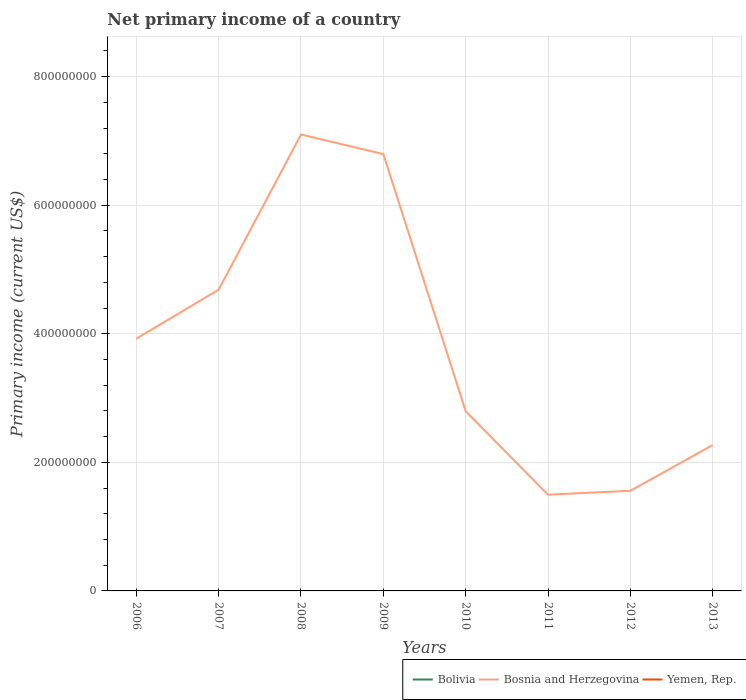Across all years, what is the maximum primary income in Bolivia?
Keep it short and to the point. 0. What is the total primary income in Bosnia and Herzegovina in the graph?
Provide a short and direct response. -2.87e+08. What is the difference between the highest and the second highest primary income in Bosnia and Herzegovina?
Your answer should be compact. 5.60e+08. Is the primary income in Bosnia and Herzegovina strictly greater than the primary income in Bolivia over the years?
Give a very brief answer. No. How many years are there in the graph?
Keep it short and to the point. 8. What is the difference between two consecutive major ticks on the Y-axis?
Give a very brief answer. 2.00e+08. Does the graph contain any zero values?
Your response must be concise. Yes. Does the graph contain grids?
Offer a terse response. Yes. How are the legend labels stacked?
Make the answer very short. Horizontal. What is the title of the graph?
Offer a very short reply. Net primary income of a country. What is the label or title of the Y-axis?
Your answer should be compact. Primary income (current US$). What is the Primary income (current US$) in Bosnia and Herzegovina in 2006?
Your response must be concise. 3.92e+08. What is the Primary income (current US$) of Yemen, Rep. in 2006?
Keep it short and to the point. 0. What is the Primary income (current US$) in Bosnia and Herzegovina in 2007?
Offer a terse response. 4.69e+08. What is the Primary income (current US$) of Yemen, Rep. in 2007?
Your answer should be compact. 0. What is the Primary income (current US$) of Bolivia in 2008?
Keep it short and to the point. 0. What is the Primary income (current US$) of Bosnia and Herzegovina in 2008?
Your answer should be compact. 7.10e+08. What is the Primary income (current US$) of Yemen, Rep. in 2008?
Ensure brevity in your answer.  0. What is the Primary income (current US$) in Bolivia in 2009?
Make the answer very short. 0. What is the Primary income (current US$) in Bosnia and Herzegovina in 2009?
Provide a short and direct response. 6.80e+08. What is the Primary income (current US$) in Yemen, Rep. in 2009?
Your answer should be very brief. 0. What is the Primary income (current US$) in Bolivia in 2010?
Ensure brevity in your answer.  0. What is the Primary income (current US$) of Bosnia and Herzegovina in 2010?
Your answer should be very brief. 2.80e+08. What is the Primary income (current US$) in Yemen, Rep. in 2010?
Give a very brief answer. 0. What is the Primary income (current US$) in Bosnia and Herzegovina in 2011?
Your answer should be very brief. 1.50e+08. What is the Primary income (current US$) of Yemen, Rep. in 2011?
Provide a short and direct response. 0. What is the Primary income (current US$) of Bolivia in 2012?
Offer a terse response. 0. What is the Primary income (current US$) in Bosnia and Herzegovina in 2012?
Make the answer very short. 1.56e+08. What is the Primary income (current US$) in Bolivia in 2013?
Your answer should be very brief. 0. What is the Primary income (current US$) in Bosnia and Herzegovina in 2013?
Provide a succinct answer. 2.27e+08. Across all years, what is the maximum Primary income (current US$) of Bosnia and Herzegovina?
Give a very brief answer. 7.10e+08. Across all years, what is the minimum Primary income (current US$) of Bosnia and Herzegovina?
Provide a short and direct response. 1.50e+08. What is the total Primary income (current US$) in Bosnia and Herzegovina in the graph?
Give a very brief answer. 3.06e+09. What is the total Primary income (current US$) of Yemen, Rep. in the graph?
Your response must be concise. 0. What is the difference between the Primary income (current US$) in Bosnia and Herzegovina in 2006 and that in 2007?
Provide a succinct answer. -7.62e+07. What is the difference between the Primary income (current US$) in Bosnia and Herzegovina in 2006 and that in 2008?
Your response must be concise. -3.18e+08. What is the difference between the Primary income (current US$) in Bosnia and Herzegovina in 2006 and that in 2009?
Ensure brevity in your answer.  -2.87e+08. What is the difference between the Primary income (current US$) of Bosnia and Herzegovina in 2006 and that in 2010?
Your answer should be very brief. 1.13e+08. What is the difference between the Primary income (current US$) in Bosnia and Herzegovina in 2006 and that in 2011?
Provide a short and direct response. 2.43e+08. What is the difference between the Primary income (current US$) of Bosnia and Herzegovina in 2006 and that in 2012?
Offer a terse response. 2.37e+08. What is the difference between the Primary income (current US$) in Bosnia and Herzegovina in 2006 and that in 2013?
Provide a succinct answer. 1.66e+08. What is the difference between the Primary income (current US$) of Bosnia and Herzegovina in 2007 and that in 2008?
Make the answer very short. -2.41e+08. What is the difference between the Primary income (current US$) of Bosnia and Herzegovina in 2007 and that in 2009?
Give a very brief answer. -2.11e+08. What is the difference between the Primary income (current US$) of Bosnia and Herzegovina in 2007 and that in 2010?
Offer a very short reply. 1.89e+08. What is the difference between the Primary income (current US$) of Bosnia and Herzegovina in 2007 and that in 2011?
Your answer should be very brief. 3.19e+08. What is the difference between the Primary income (current US$) in Bosnia and Herzegovina in 2007 and that in 2012?
Your answer should be very brief. 3.13e+08. What is the difference between the Primary income (current US$) in Bosnia and Herzegovina in 2007 and that in 2013?
Offer a terse response. 2.42e+08. What is the difference between the Primary income (current US$) in Bosnia and Herzegovina in 2008 and that in 2009?
Give a very brief answer. 3.04e+07. What is the difference between the Primary income (current US$) of Bosnia and Herzegovina in 2008 and that in 2010?
Provide a succinct answer. 4.30e+08. What is the difference between the Primary income (current US$) of Bosnia and Herzegovina in 2008 and that in 2011?
Your answer should be very brief. 5.60e+08. What is the difference between the Primary income (current US$) in Bosnia and Herzegovina in 2008 and that in 2012?
Ensure brevity in your answer.  5.54e+08. What is the difference between the Primary income (current US$) of Bosnia and Herzegovina in 2008 and that in 2013?
Offer a terse response. 4.83e+08. What is the difference between the Primary income (current US$) in Bosnia and Herzegovina in 2009 and that in 2010?
Make the answer very short. 4.00e+08. What is the difference between the Primary income (current US$) in Bosnia and Herzegovina in 2009 and that in 2011?
Offer a terse response. 5.30e+08. What is the difference between the Primary income (current US$) of Bosnia and Herzegovina in 2009 and that in 2012?
Provide a succinct answer. 5.24e+08. What is the difference between the Primary income (current US$) of Bosnia and Herzegovina in 2009 and that in 2013?
Your response must be concise. 4.53e+08. What is the difference between the Primary income (current US$) of Bosnia and Herzegovina in 2010 and that in 2011?
Provide a succinct answer. 1.30e+08. What is the difference between the Primary income (current US$) of Bosnia and Herzegovina in 2010 and that in 2012?
Your answer should be very brief. 1.24e+08. What is the difference between the Primary income (current US$) in Bosnia and Herzegovina in 2010 and that in 2013?
Keep it short and to the point. 5.26e+07. What is the difference between the Primary income (current US$) in Bosnia and Herzegovina in 2011 and that in 2012?
Give a very brief answer. -6.13e+06. What is the difference between the Primary income (current US$) of Bosnia and Herzegovina in 2011 and that in 2013?
Provide a short and direct response. -7.72e+07. What is the difference between the Primary income (current US$) of Bosnia and Herzegovina in 2012 and that in 2013?
Offer a very short reply. -7.11e+07. What is the average Primary income (current US$) of Bosnia and Herzegovina per year?
Provide a succinct answer. 3.83e+08. What is the average Primary income (current US$) in Yemen, Rep. per year?
Ensure brevity in your answer.  0. What is the ratio of the Primary income (current US$) of Bosnia and Herzegovina in 2006 to that in 2007?
Make the answer very short. 0.84. What is the ratio of the Primary income (current US$) in Bosnia and Herzegovina in 2006 to that in 2008?
Your response must be concise. 0.55. What is the ratio of the Primary income (current US$) of Bosnia and Herzegovina in 2006 to that in 2009?
Your response must be concise. 0.58. What is the ratio of the Primary income (current US$) in Bosnia and Herzegovina in 2006 to that in 2010?
Provide a short and direct response. 1.4. What is the ratio of the Primary income (current US$) of Bosnia and Herzegovina in 2006 to that in 2011?
Provide a succinct answer. 2.62. What is the ratio of the Primary income (current US$) in Bosnia and Herzegovina in 2006 to that in 2012?
Your answer should be compact. 2.52. What is the ratio of the Primary income (current US$) in Bosnia and Herzegovina in 2006 to that in 2013?
Ensure brevity in your answer.  1.73. What is the ratio of the Primary income (current US$) in Bosnia and Herzegovina in 2007 to that in 2008?
Offer a very short reply. 0.66. What is the ratio of the Primary income (current US$) in Bosnia and Herzegovina in 2007 to that in 2009?
Make the answer very short. 0.69. What is the ratio of the Primary income (current US$) of Bosnia and Herzegovina in 2007 to that in 2010?
Ensure brevity in your answer.  1.68. What is the ratio of the Primary income (current US$) of Bosnia and Herzegovina in 2007 to that in 2011?
Offer a terse response. 3.13. What is the ratio of the Primary income (current US$) of Bosnia and Herzegovina in 2007 to that in 2012?
Your answer should be very brief. 3.01. What is the ratio of the Primary income (current US$) of Bosnia and Herzegovina in 2007 to that in 2013?
Your answer should be very brief. 2.07. What is the ratio of the Primary income (current US$) of Bosnia and Herzegovina in 2008 to that in 2009?
Keep it short and to the point. 1.04. What is the ratio of the Primary income (current US$) of Bosnia and Herzegovina in 2008 to that in 2010?
Make the answer very short. 2.54. What is the ratio of the Primary income (current US$) in Bosnia and Herzegovina in 2008 to that in 2011?
Keep it short and to the point. 4.74. What is the ratio of the Primary income (current US$) of Bosnia and Herzegovina in 2008 to that in 2012?
Give a very brief answer. 4.56. What is the ratio of the Primary income (current US$) of Bosnia and Herzegovina in 2008 to that in 2013?
Ensure brevity in your answer.  3.13. What is the ratio of the Primary income (current US$) of Bosnia and Herzegovina in 2009 to that in 2010?
Your answer should be very brief. 2.43. What is the ratio of the Primary income (current US$) of Bosnia and Herzegovina in 2009 to that in 2011?
Provide a short and direct response. 4.54. What is the ratio of the Primary income (current US$) in Bosnia and Herzegovina in 2009 to that in 2012?
Provide a succinct answer. 4.36. What is the ratio of the Primary income (current US$) in Bosnia and Herzegovina in 2009 to that in 2013?
Offer a very short reply. 2.99. What is the ratio of the Primary income (current US$) of Bosnia and Herzegovina in 2010 to that in 2011?
Ensure brevity in your answer.  1.87. What is the ratio of the Primary income (current US$) of Bosnia and Herzegovina in 2010 to that in 2012?
Your answer should be very brief. 1.79. What is the ratio of the Primary income (current US$) in Bosnia and Herzegovina in 2010 to that in 2013?
Provide a succinct answer. 1.23. What is the ratio of the Primary income (current US$) of Bosnia and Herzegovina in 2011 to that in 2012?
Your response must be concise. 0.96. What is the ratio of the Primary income (current US$) of Bosnia and Herzegovina in 2011 to that in 2013?
Ensure brevity in your answer.  0.66. What is the ratio of the Primary income (current US$) in Bosnia and Herzegovina in 2012 to that in 2013?
Provide a succinct answer. 0.69. What is the difference between the highest and the second highest Primary income (current US$) in Bosnia and Herzegovina?
Your answer should be very brief. 3.04e+07. What is the difference between the highest and the lowest Primary income (current US$) in Bosnia and Herzegovina?
Provide a succinct answer. 5.60e+08. 